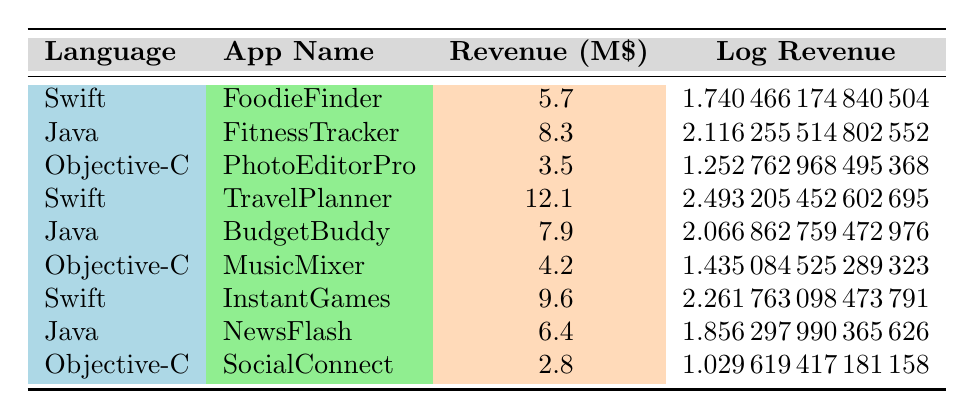What is the annual revenue for the app "TravelPlanner"? The app "TravelPlanner" is listed under the programming language Swift in the table, and its annual revenue is shown as 12.1 million dollars.
Answer: 12.1 million dollars Which programming language has the highest revenue app? The app with the highest revenue is "TravelPlanner" at 12.1 million dollars, which is developed in Swift. Therefore, Swift has the highest revenue app.
Answer: Swift What is the total revenue generated by Objective-C apps? The Objective-C apps listed are "PhotoEditorPro" (3.5 million), "MusicMixer" (4.2 million), and "SocialConnect" (2.8 million). Summing these values gives 3.5 + 4.2 + 2.8 = 10.5 million dollars.
Answer: 10.5 million dollars Is the average revenue of Java apps greater than that of Swift apps? The Java apps listed are “FitnessTracker” (8.3 million), “BudgetBuddy” (7.9 million), and “NewsFlash” (6.4 million). The total is 8.3 + 7.9 + 6.4 = 22.6 million, so the average is 22.6 / 3 = 7.53 million. The Swift apps are “FoodieFinder” (5.7 million), “TravelPlanner” (12.1 million), and “InstantGames” (9.6 million). The total is 5.7 + 12.1 + 9.6 = 27.4 million, and the average is 27.4 / 3 = 9.13 million. Since 7.53 million is less than 9.13 million, the average revenue of Java apps is not greater.
Answer: No Does the app "MusicMixer" generate more revenue than "BudgetBuddy"? "MusicMixer" generates 4.2 million dollars, while "BudgetBuddy" generates 7.9 million dollars. Since 4.2 million is less than 7.9 million, "MusicMixer" does not generate more revenue.
Answer: No 